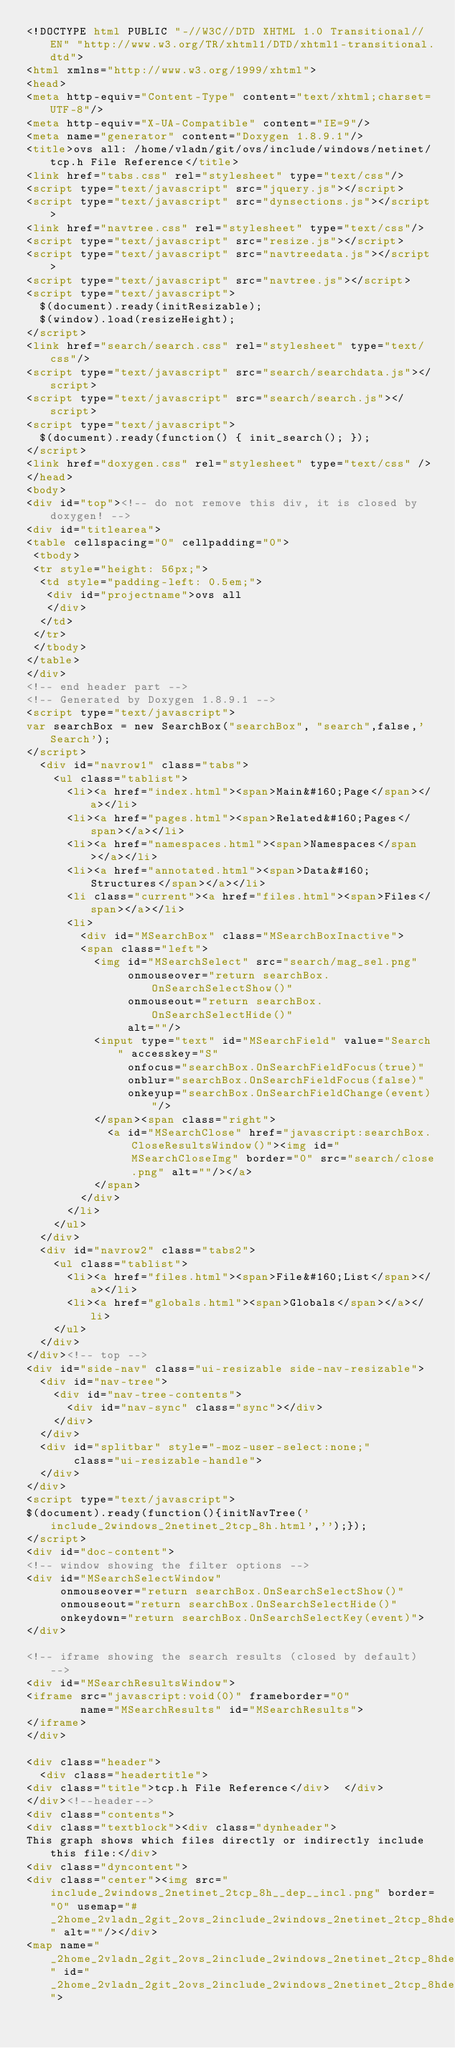Convert code to text. <code><loc_0><loc_0><loc_500><loc_500><_HTML_><!DOCTYPE html PUBLIC "-//W3C//DTD XHTML 1.0 Transitional//EN" "http://www.w3.org/TR/xhtml1/DTD/xhtml1-transitional.dtd">
<html xmlns="http://www.w3.org/1999/xhtml">
<head>
<meta http-equiv="Content-Type" content="text/xhtml;charset=UTF-8"/>
<meta http-equiv="X-UA-Compatible" content="IE=9"/>
<meta name="generator" content="Doxygen 1.8.9.1"/>
<title>ovs all: /home/vladn/git/ovs/include/windows/netinet/tcp.h File Reference</title>
<link href="tabs.css" rel="stylesheet" type="text/css"/>
<script type="text/javascript" src="jquery.js"></script>
<script type="text/javascript" src="dynsections.js"></script>
<link href="navtree.css" rel="stylesheet" type="text/css"/>
<script type="text/javascript" src="resize.js"></script>
<script type="text/javascript" src="navtreedata.js"></script>
<script type="text/javascript" src="navtree.js"></script>
<script type="text/javascript">
  $(document).ready(initResizable);
  $(window).load(resizeHeight);
</script>
<link href="search/search.css" rel="stylesheet" type="text/css"/>
<script type="text/javascript" src="search/searchdata.js"></script>
<script type="text/javascript" src="search/search.js"></script>
<script type="text/javascript">
  $(document).ready(function() { init_search(); });
</script>
<link href="doxygen.css" rel="stylesheet" type="text/css" />
</head>
<body>
<div id="top"><!-- do not remove this div, it is closed by doxygen! -->
<div id="titlearea">
<table cellspacing="0" cellpadding="0">
 <tbody>
 <tr style="height: 56px;">
  <td style="padding-left: 0.5em;">
   <div id="projectname">ovs all
   </div>
  </td>
 </tr>
 </tbody>
</table>
</div>
<!-- end header part -->
<!-- Generated by Doxygen 1.8.9.1 -->
<script type="text/javascript">
var searchBox = new SearchBox("searchBox", "search",false,'Search');
</script>
  <div id="navrow1" class="tabs">
    <ul class="tablist">
      <li><a href="index.html"><span>Main&#160;Page</span></a></li>
      <li><a href="pages.html"><span>Related&#160;Pages</span></a></li>
      <li><a href="namespaces.html"><span>Namespaces</span></a></li>
      <li><a href="annotated.html"><span>Data&#160;Structures</span></a></li>
      <li class="current"><a href="files.html"><span>Files</span></a></li>
      <li>
        <div id="MSearchBox" class="MSearchBoxInactive">
        <span class="left">
          <img id="MSearchSelect" src="search/mag_sel.png"
               onmouseover="return searchBox.OnSearchSelectShow()"
               onmouseout="return searchBox.OnSearchSelectHide()"
               alt=""/>
          <input type="text" id="MSearchField" value="Search" accesskey="S"
               onfocus="searchBox.OnSearchFieldFocus(true)" 
               onblur="searchBox.OnSearchFieldFocus(false)" 
               onkeyup="searchBox.OnSearchFieldChange(event)"/>
          </span><span class="right">
            <a id="MSearchClose" href="javascript:searchBox.CloseResultsWindow()"><img id="MSearchCloseImg" border="0" src="search/close.png" alt=""/></a>
          </span>
        </div>
      </li>
    </ul>
  </div>
  <div id="navrow2" class="tabs2">
    <ul class="tablist">
      <li><a href="files.html"><span>File&#160;List</span></a></li>
      <li><a href="globals.html"><span>Globals</span></a></li>
    </ul>
  </div>
</div><!-- top -->
<div id="side-nav" class="ui-resizable side-nav-resizable">
  <div id="nav-tree">
    <div id="nav-tree-contents">
      <div id="nav-sync" class="sync"></div>
    </div>
  </div>
  <div id="splitbar" style="-moz-user-select:none;" 
       class="ui-resizable-handle">
  </div>
</div>
<script type="text/javascript">
$(document).ready(function(){initNavTree('include_2windows_2netinet_2tcp_8h.html','');});
</script>
<div id="doc-content">
<!-- window showing the filter options -->
<div id="MSearchSelectWindow"
     onmouseover="return searchBox.OnSearchSelectShow()"
     onmouseout="return searchBox.OnSearchSelectHide()"
     onkeydown="return searchBox.OnSearchSelectKey(event)">
</div>

<!-- iframe showing the search results (closed by default) -->
<div id="MSearchResultsWindow">
<iframe src="javascript:void(0)" frameborder="0" 
        name="MSearchResults" id="MSearchResults">
</iframe>
</div>

<div class="header">
  <div class="headertitle">
<div class="title">tcp.h File Reference</div>  </div>
</div><!--header-->
<div class="contents">
<div class="textblock"><div class="dynheader">
This graph shows which files directly or indirectly include this file:</div>
<div class="dyncontent">
<div class="center"><img src="include_2windows_2netinet_2tcp_8h__dep__incl.png" border="0" usemap="#_2home_2vladn_2git_2ovs_2include_2windows_2netinet_2tcp_8hdep" alt=""/></div>
<map name="_2home_2vladn_2git_2ovs_2include_2windows_2netinet_2tcp_8hdep" id="_2home_2vladn_2git_2ovs_2include_2windows_2netinet_2tcp_8hdep"></code> 